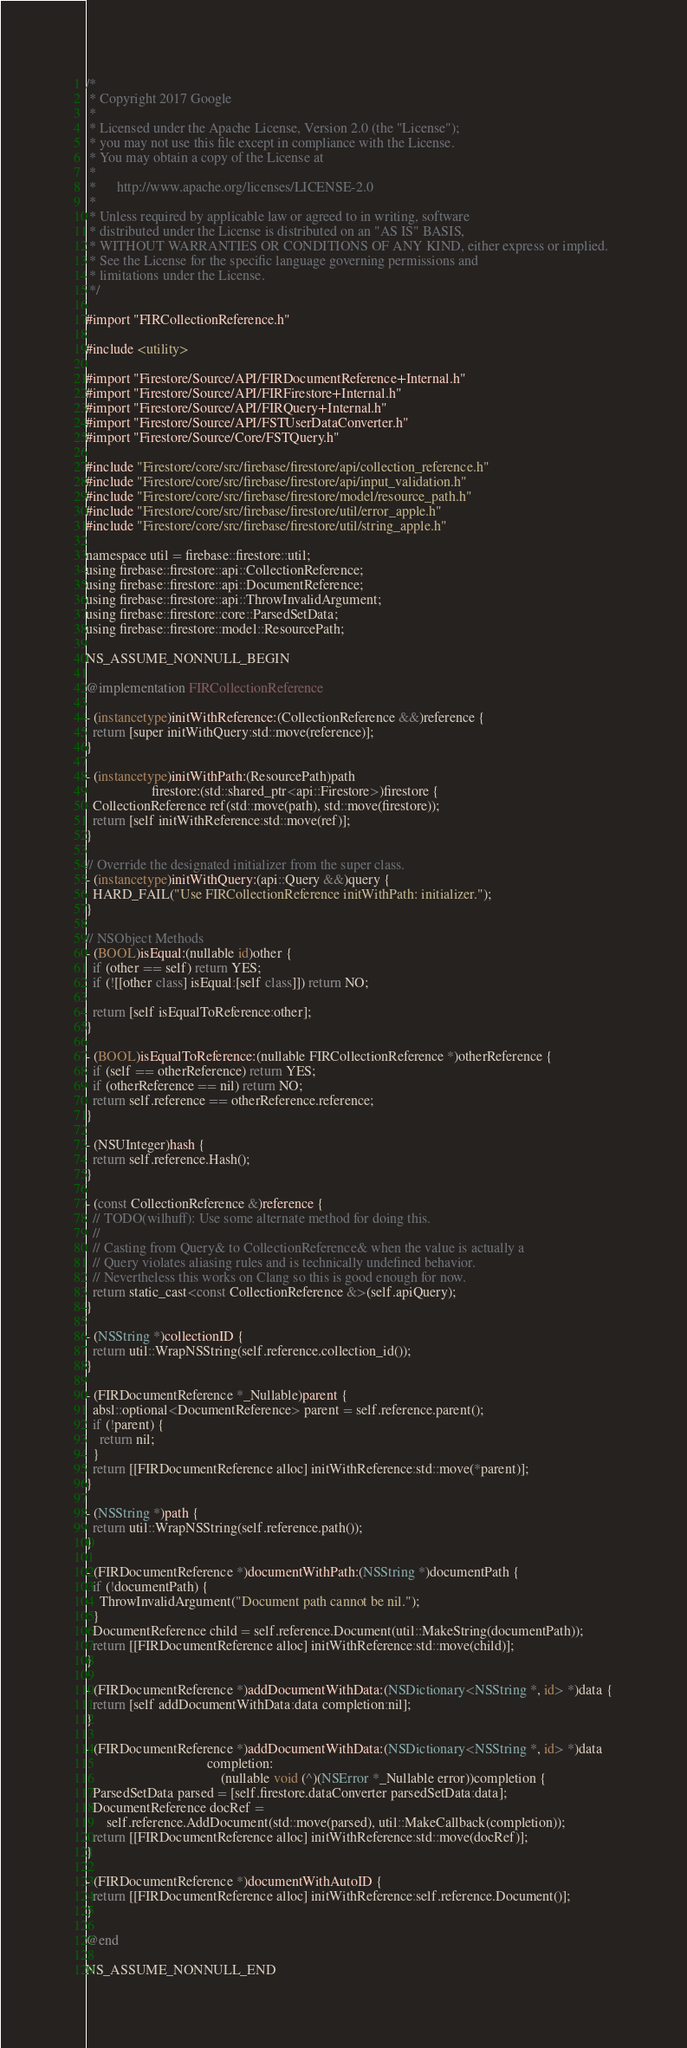Convert code to text. <code><loc_0><loc_0><loc_500><loc_500><_ObjectiveC_>/*
 * Copyright 2017 Google
 *
 * Licensed under the Apache License, Version 2.0 (the "License");
 * you may not use this file except in compliance with the License.
 * You may obtain a copy of the License at
 *
 *      http://www.apache.org/licenses/LICENSE-2.0
 *
 * Unless required by applicable law or agreed to in writing, software
 * distributed under the License is distributed on an "AS IS" BASIS,
 * WITHOUT WARRANTIES OR CONDITIONS OF ANY KIND, either express or implied.
 * See the License for the specific language governing permissions and
 * limitations under the License.
 */

#import "FIRCollectionReference.h"

#include <utility>

#import "Firestore/Source/API/FIRDocumentReference+Internal.h"
#import "Firestore/Source/API/FIRFirestore+Internal.h"
#import "Firestore/Source/API/FIRQuery+Internal.h"
#import "Firestore/Source/API/FSTUserDataConverter.h"
#import "Firestore/Source/Core/FSTQuery.h"

#include "Firestore/core/src/firebase/firestore/api/collection_reference.h"
#include "Firestore/core/src/firebase/firestore/api/input_validation.h"
#include "Firestore/core/src/firebase/firestore/model/resource_path.h"
#include "Firestore/core/src/firebase/firestore/util/error_apple.h"
#include "Firestore/core/src/firebase/firestore/util/string_apple.h"

namespace util = firebase::firestore::util;
using firebase::firestore::api::CollectionReference;
using firebase::firestore::api::DocumentReference;
using firebase::firestore::api::ThrowInvalidArgument;
using firebase::firestore::core::ParsedSetData;
using firebase::firestore::model::ResourcePath;

NS_ASSUME_NONNULL_BEGIN

@implementation FIRCollectionReference

- (instancetype)initWithReference:(CollectionReference &&)reference {
  return [super initWithQuery:std::move(reference)];
}

- (instancetype)initWithPath:(ResourcePath)path
                   firestore:(std::shared_ptr<api::Firestore>)firestore {
  CollectionReference ref(std::move(path), std::move(firestore));
  return [self initWithReference:std::move(ref)];
}

// Override the designated initializer from the super class.
- (instancetype)initWithQuery:(api::Query &&)query {
  HARD_FAIL("Use FIRCollectionReference initWithPath: initializer.");
}

// NSObject Methods
- (BOOL)isEqual:(nullable id)other {
  if (other == self) return YES;
  if (![[other class] isEqual:[self class]]) return NO;

  return [self isEqualToReference:other];
}

- (BOOL)isEqualToReference:(nullable FIRCollectionReference *)otherReference {
  if (self == otherReference) return YES;
  if (otherReference == nil) return NO;
  return self.reference == otherReference.reference;
}

- (NSUInteger)hash {
  return self.reference.Hash();
}

- (const CollectionReference &)reference {
  // TODO(wilhuff): Use some alternate method for doing this.
  //
  // Casting from Query& to CollectionReference& when the value is actually a
  // Query violates aliasing rules and is technically undefined behavior.
  // Nevertheless this works on Clang so this is good enough for now.
  return static_cast<const CollectionReference &>(self.apiQuery);
}

- (NSString *)collectionID {
  return util::WrapNSString(self.reference.collection_id());
}

- (FIRDocumentReference *_Nullable)parent {
  absl::optional<DocumentReference> parent = self.reference.parent();
  if (!parent) {
    return nil;
  }
  return [[FIRDocumentReference alloc] initWithReference:std::move(*parent)];
}

- (NSString *)path {
  return util::WrapNSString(self.reference.path());
}

- (FIRDocumentReference *)documentWithPath:(NSString *)documentPath {
  if (!documentPath) {
    ThrowInvalidArgument("Document path cannot be nil.");
  }
  DocumentReference child = self.reference.Document(util::MakeString(documentPath));
  return [[FIRDocumentReference alloc] initWithReference:std::move(child)];
}

- (FIRDocumentReference *)addDocumentWithData:(NSDictionary<NSString *, id> *)data {
  return [self addDocumentWithData:data completion:nil];
}

- (FIRDocumentReference *)addDocumentWithData:(NSDictionary<NSString *, id> *)data
                                   completion:
                                       (nullable void (^)(NSError *_Nullable error))completion {
  ParsedSetData parsed = [self.firestore.dataConverter parsedSetData:data];
  DocumentReference docRef =
      self.reference.AddDocument(std::move(parsed), util::MakeCallback(completion));
  return [[FIRDocumentReference alloc] initWithReference:std::move(docRef)];
}

- (FIRDocumentReference *)documentWithAutoID {
  return [[FIRDocumentReference alloc] initWithReference:self.reference.Document()];
}

@end

NS_ASSUME_NONNULL_END
</code> 